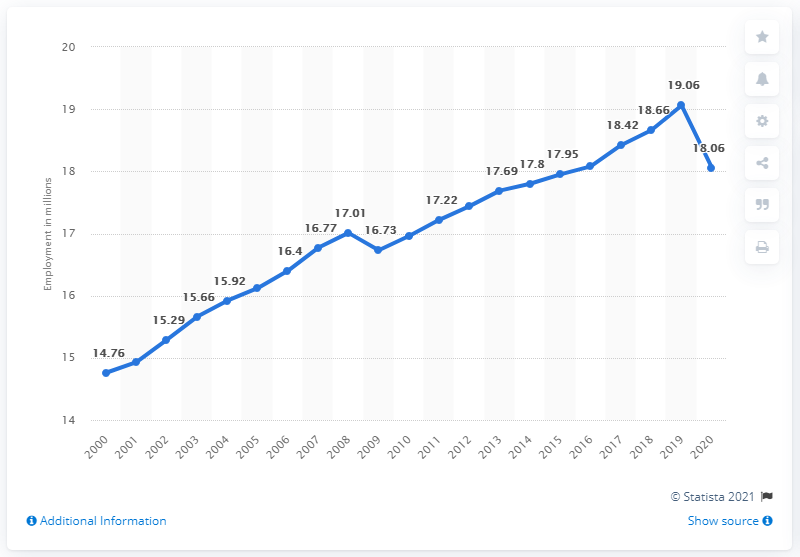Identify some key points in this picture. In 2020, the number of people aged 15 and over who were employed in Canada was 18.06 million. 